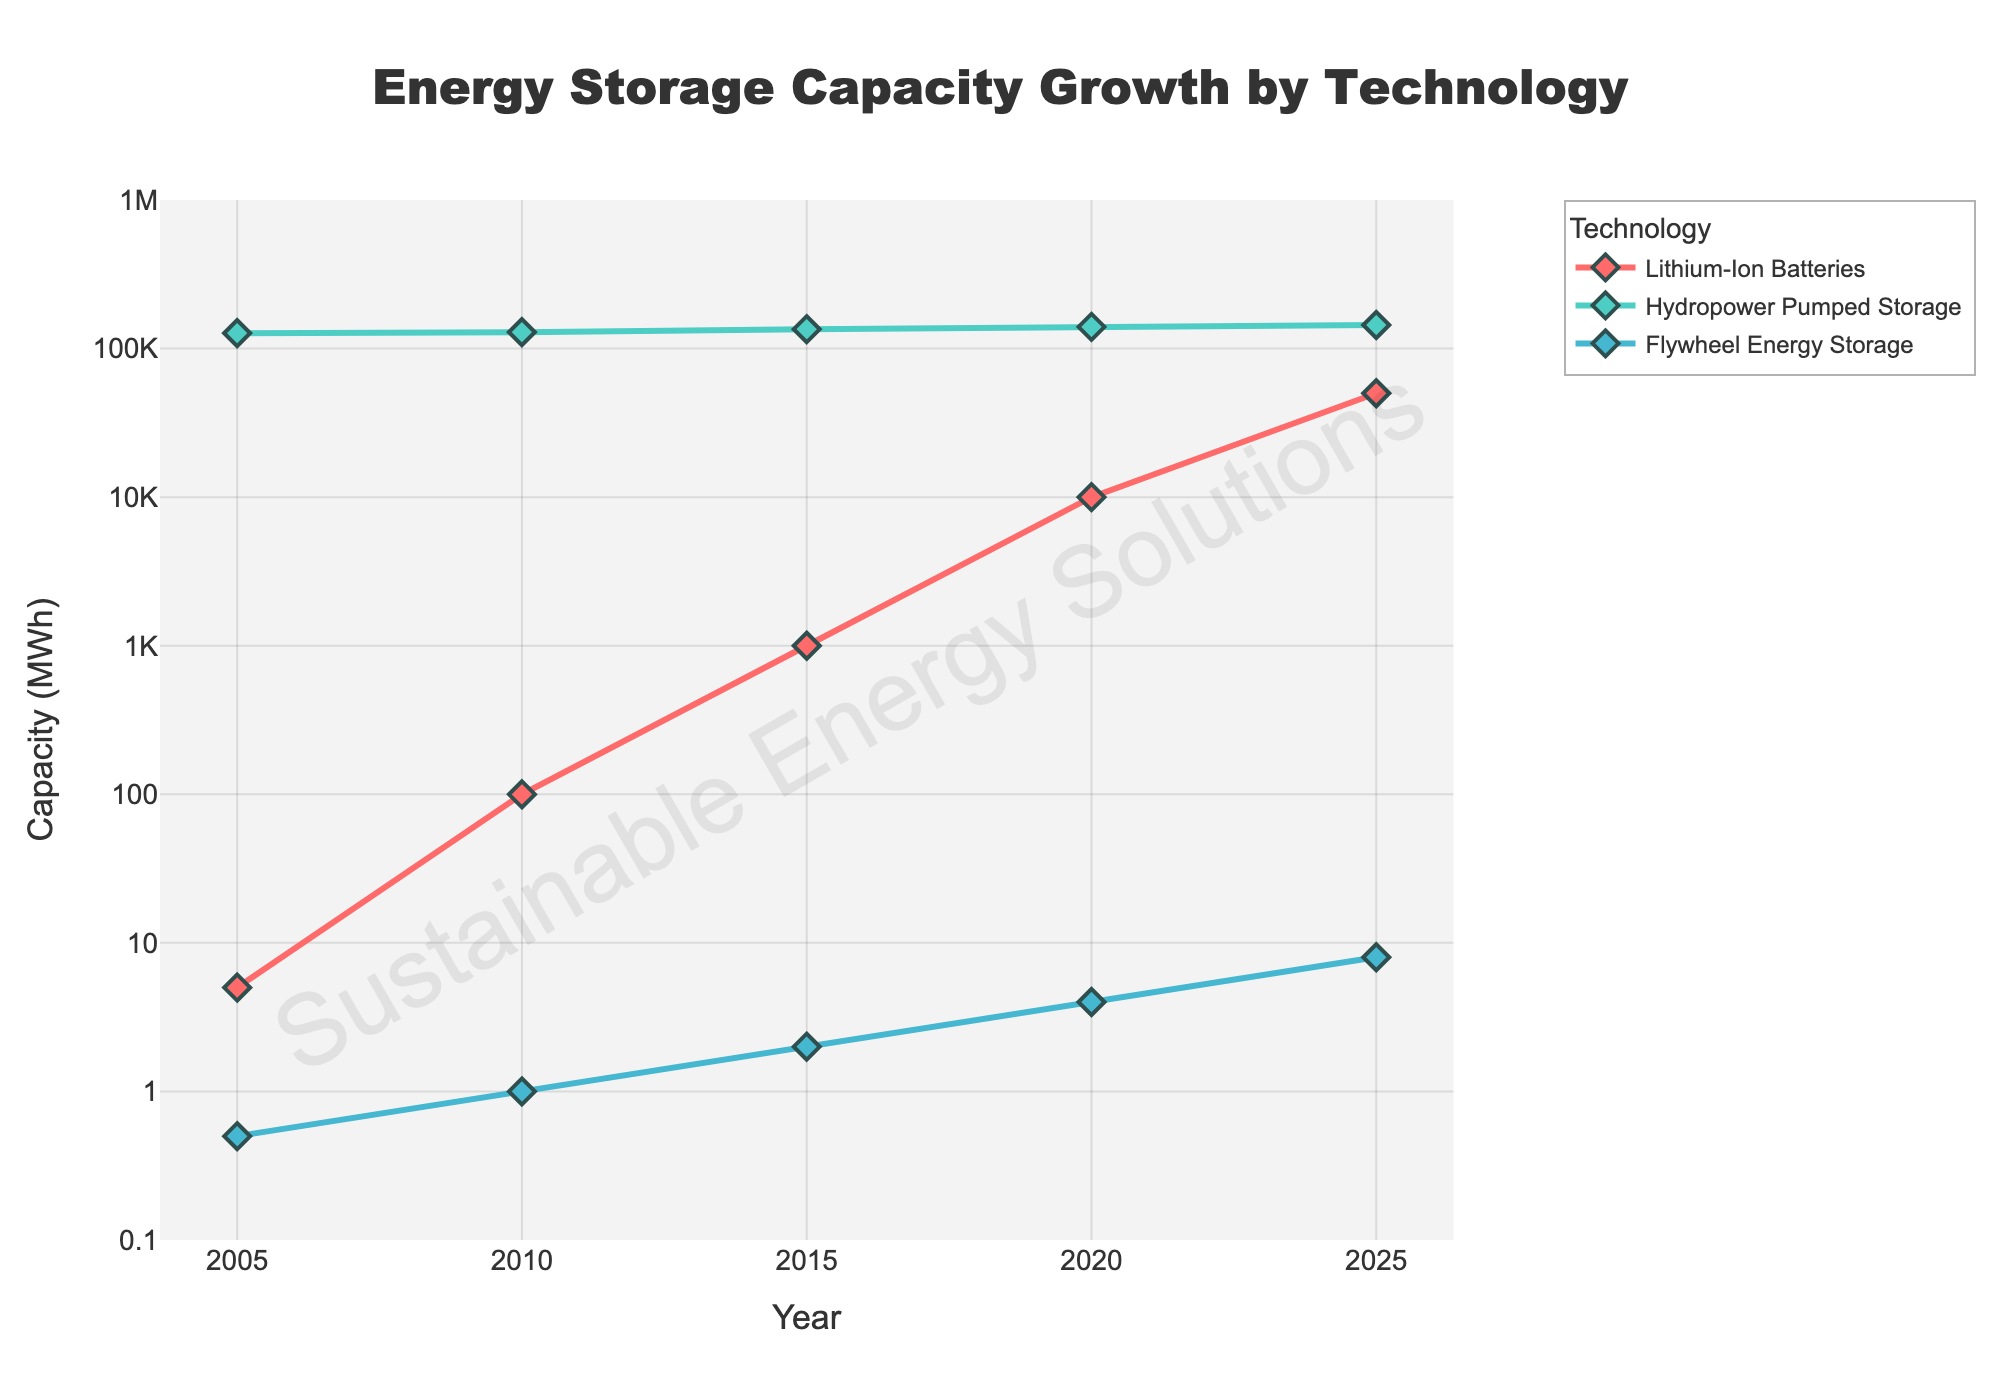What is the title of the figure? The title is located at the top of the figure and is typically centered. By observing the figure, we can read the text in the title section.
Answer: Energy Storage Capacity Growth by Technology How does the capacity of Lithium-Ion Batteries change from 2005 to 2025? Locate the line for Lithium-Ion Batteries. Starting from 5 MWh in 2005, increasing to 100 MWh in 2010, 1000 MWh in 2015, 10000 MWh in 2020, and finally reaching 50000 MWh in 2025.
Answer: It significantly increases Which technology has the highest capacity in 2025? Compare the capacity values of all technologies in 2025. Lithium-Ion Batteries have 50000 MWh, Hydropower Pumped Storage has 144000 MWh, and Flywheel Energy Storage has 8 MWh.
Answer: Hydropower Pumped Storage By how much did the capacity of Flywheel Energy Storage increase from 2005 to 2025? Calculate the difference between Flywheel Energy Storage capacity in 2025 (8 MWh) and 2005 (0.5 MWh). The increase is 8 - 0.5 = 7.5 MWh.
Answer: 7.5 MWh Which technology experienced the fastest rate of growth between 2005 and 2025? Look at the slopes of the lines for each technology. Lithium-Ion Batteries grew from 5 MWh to 50000 MWh, Hydropower Pumped Storage from 127000 MWh to 144000 MWh, and Flywheel Energy Storage from 0.5 MWh to 8 MWh. The steepest slope indicates the fastest growth rate.
Answer: Lithium-Ion Batteries What is the log-scaled range on the y-axis? The y-axis range can be observed directly from the figure's axis. It ranges from 0.1 to 1000000 MWh as indicated by the tick marks.
Answer: 0.1 to 1000000 MWh How many data points are there for each technology across the years? Count the markers (diamonds) for each technology. The years given are 2005, 2010, 2015, 2020, and 2025, which means there are 5 data points per technology.
Answer: 5 How does the growth of Hydropower Pumped Storage compare to the growth of Lithium-Ion Batteries over the years? Analyze the trend lines. Hydropower Pumped Storage has a relatively flat line with slight increases, whereas Lithium-Ion Batteries show a steep, upward trend. This indicates a much faster growth rate for Lithium-Ion Batteries compared to Hydropower Pumped Storage.
Answer: Lithium-Ion Batteries grew faster What trend can be observed in the capacity of Flywheel Energy Storage from 2005 to 2025? The Flywheel Energy Storage capacity data points can be observed: they start at 0.5 MWh in 2005 and gradually increase to 8 MWh by 2025. The trend shows steady incremental growth.
Answer: Steady incremental growth 